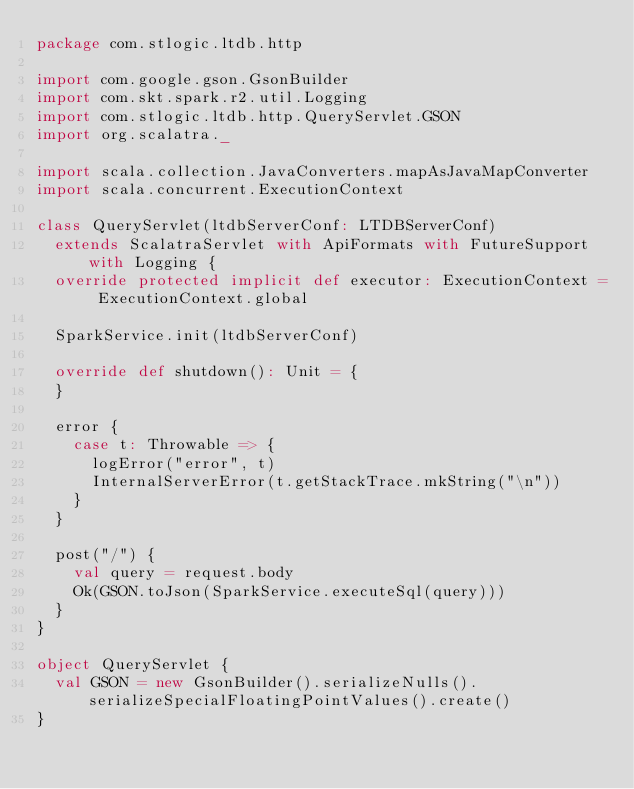Convert code to text. <code><loc_0><loc_0><loc_500><loc_500><_Scala_>package com.stlogic.ltdb.http

import com.google.gson.GsonBuilder
import com.skt.spark.r2.util.Logging
import com.stlogic.ltdb.http.QueryServlet.GSON
import org.scalatra._

import scala.collection.JavaConverters.mapAsJavaMapConverter
import scala.concurrent.ExecutionContext

class QueryServlet(ltdbServerConf: LTDBServerConf)
  extends ScalatraServlet with ApiFormats with FutureSupport with Logging {
  override protected implicit def executor: ExecutionContext = ExecutionContext.global

  SparkService.init(ltdbServerConf)

  override def shutdown(): Unit = {
  }

  error {
    case t: Throwable => {
      logError("error", t)
      InternalServerError(t.getStackTrace.mkString("\n"))
    }
  }

  post("/") {
    val query = request.body
    Ok(GSON.toJson(SparkService.executeSql(query)))
  }
}

object QueryServlet {
  val GSON = new GsonBuilder().serializeNulls().serializeSpecialFloatingPointValues().create()
}</code> 